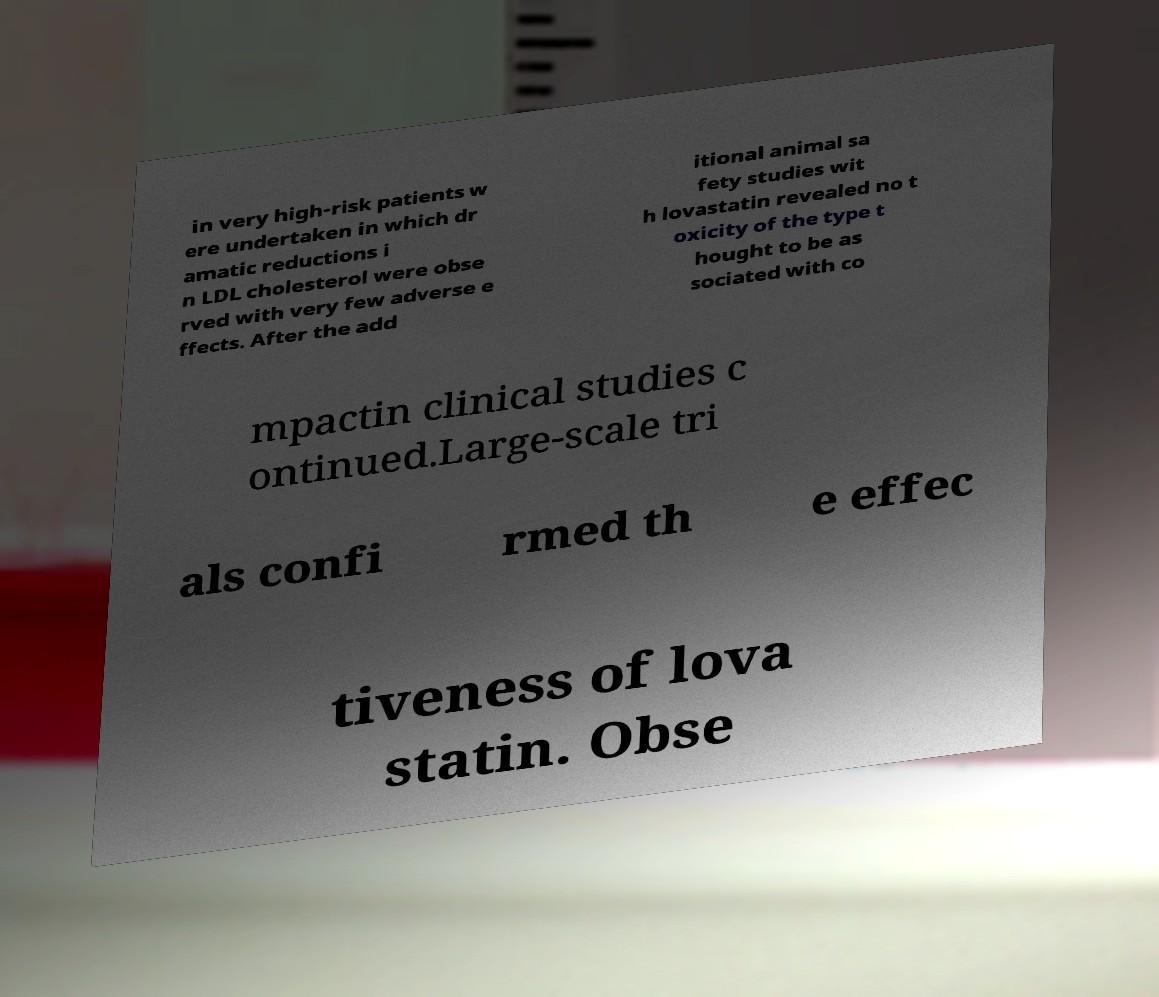I need the written content from this picture converted into text. Can you do that? in very high-risk patients w ere undertaken in which dr amatic reductions i n LDL cholesterol were obse rved with very few adverse e ffects. After the add itional animal sa fety studies wit h lovastatin revealed no t oxicity of the type t hought to be as sociated with co mpactin clinical studies c ontinued.Large-scale tri als confi rmed th e effec tiveness of lova statin. Obse 